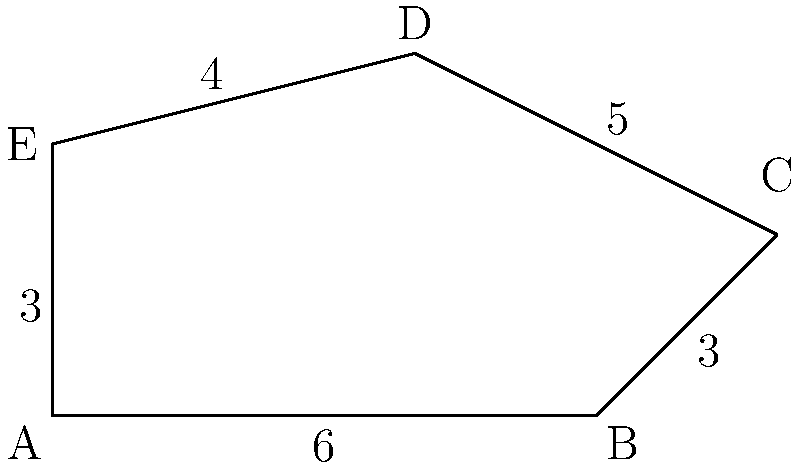You're planning to fence your irregularly shaped farmland plot to protect your crops. Given the dimensions shown in the diagram (in hundreds of meters), calculate the total length of fencing needed to enclose the entire plot. To find the perimeter of the irregular-shaped farmland plot, we need to add up the lengths of all sides:

1. Side AB: 6 hundred meters
2. Side BC: 3 hundred meters
3. Side CD: 5 hundred meters
4. Side DE: 4 hundred meters
5. Side EA: 3 hundred meters

Total perimeter = AB + BC + CD + DE + EA
$$ \text{Perimeter} = 6 + 3 + 5 + 4 + 3 = 21 $$

The total perimeter is 21 hundred meters, or 2,100 meters.
Answer: 2,100 meters 